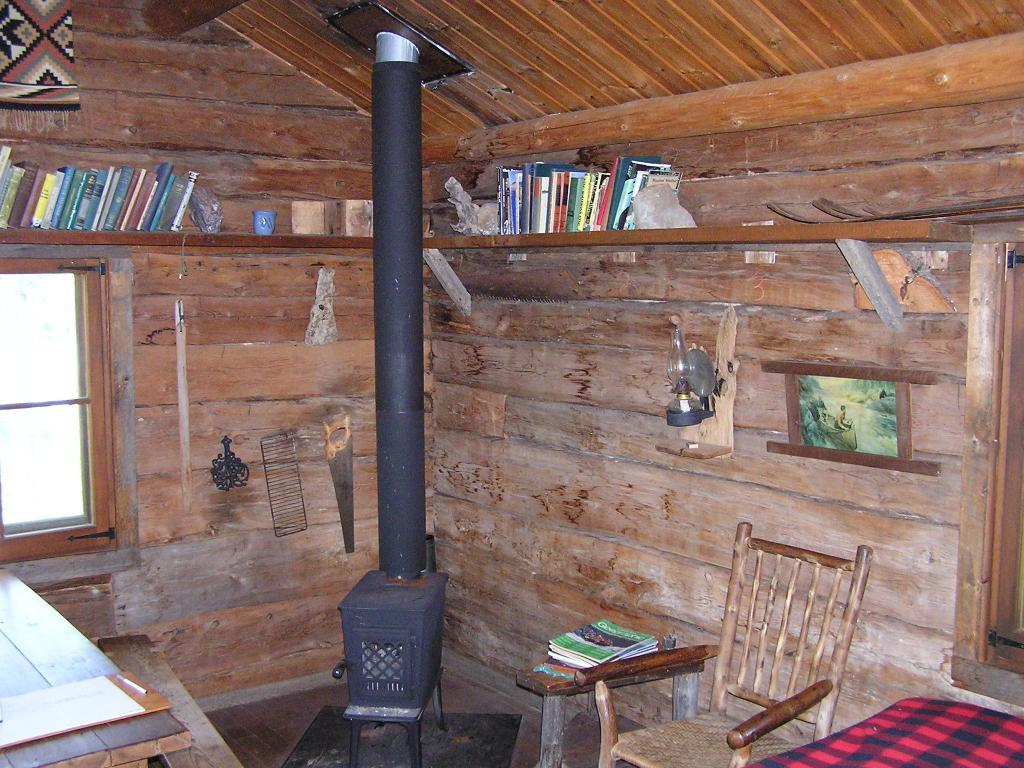What can be seen on the rack in the image? There is a rack with books in the image. What type of furniture is present in the image? There is a chair and a table in the image. What might be used for reading or studying in the image? The rack with books and the chair could be used for reading or studying. What is hanging on the wall in the image? There is a photo frame in the image. What can be seen in the background of the image? There is a window visible in the background of the image. What color is the stream visible through the window in the image? There is no stream visible through the window in the image; it is a window, not a stream. What rule is being enforced by the photo frame in the image? There is no rule being enforced by the photo frame in the image; it is a decorative object. 